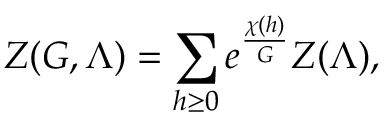Convert formula to latex. <formula><loc_0><loc_0><loc_500><loc_500>Z ( G , \Lambda ) = \sum _ { h \geq 0 } e ^ { \frac { \chi ( h ) } { G } } Z ( \Lambda ) ,</formula> 